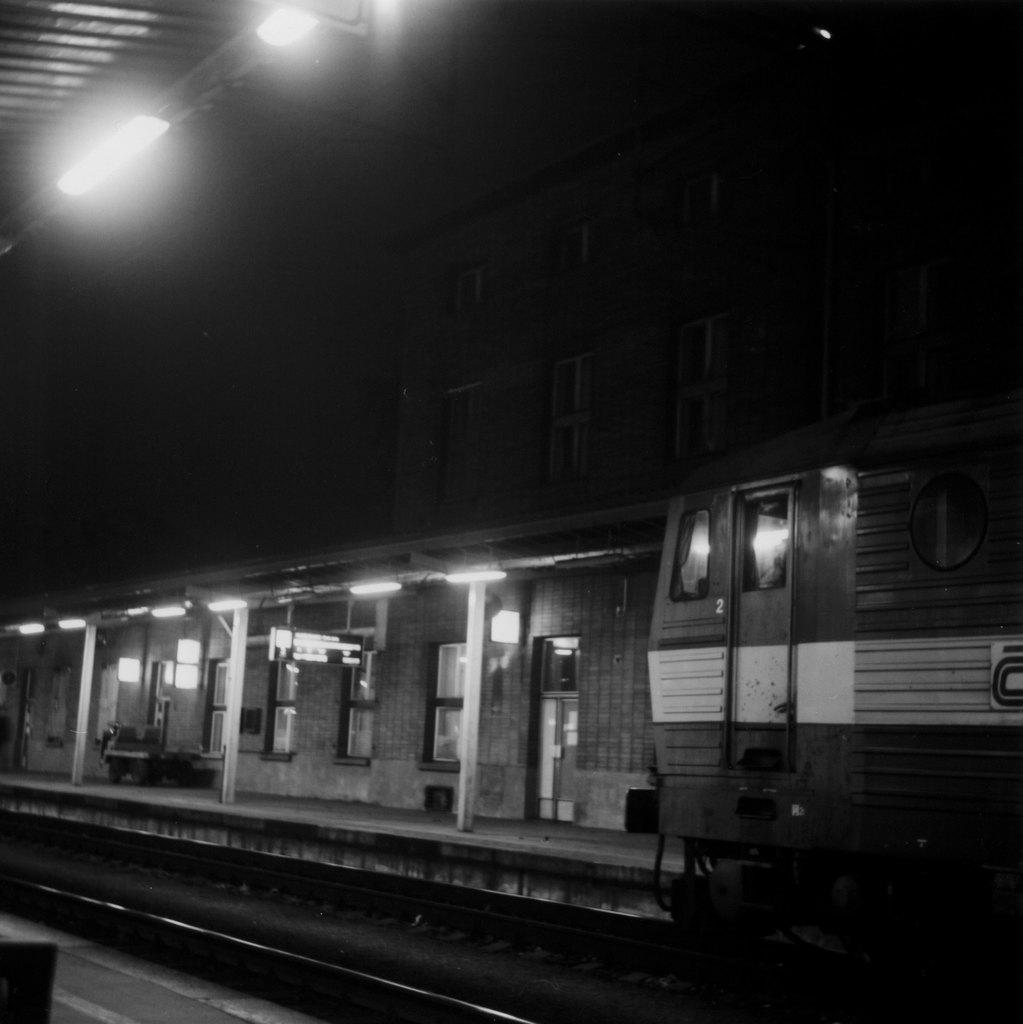What is the main subject of the image? The main subject of the image is a railway track. What is on the railway track? There is a train on the railway track. What can be seen on the platform near the railway track? There are lights visible on the platform. What type of wine is being served on the train in the image? There is no wine or indication of food or drink being served on the train in the image. 